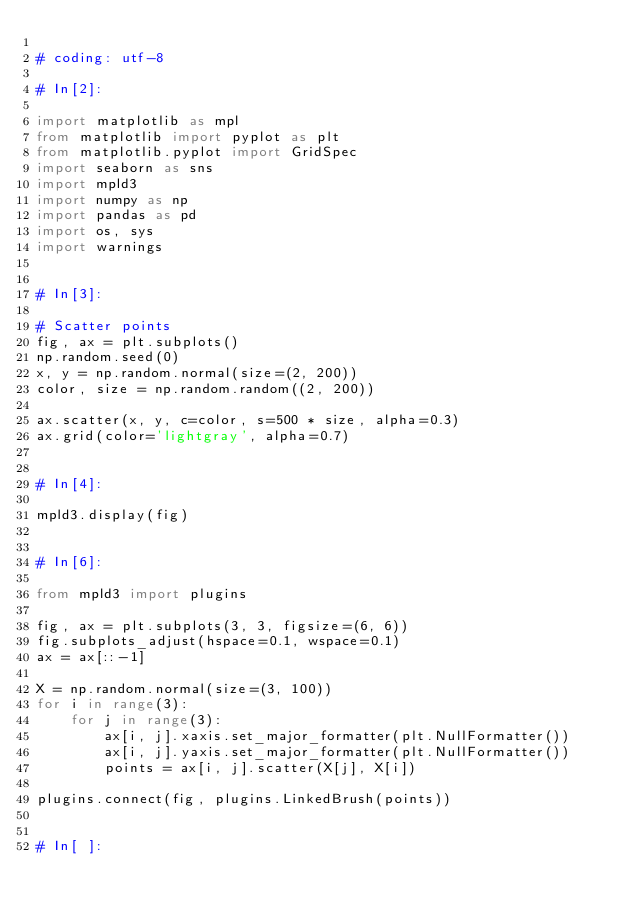Convert code to text. <code><loc_0><loc_0><loc_500><loc_500><_Python_>
# coding: utf-8

# In[2]:

import matplotlib as mpl
from matplotlib import pyplot as plt
from matplotlib.pyplot import GridSpec
import seaborn as sns
import mpld3
import numpy as np
import pandas as pd
import os, sys
import warnings


# In[3]:

# Scatter points
fig, ax = plt.subplots()
np.random.seed(0)
x, y = np.random.normal(size=(2, 200))
color, size = np.random.random((2, 200))

ax.scatter(x, y, c=color, s=500 * size, alpha=0.3)
ax.grid(color='lightgray', alpha=0.7)


# In[4]:

mpld3.display(fig)


# In[6]:

from mpld3 import plugins

fig, ax = plt.subplots(3, 3, figsize=(6, 6))
fig.subplots_adjust(hspace=0.1, wspace=0.1)
ax = ax[::-1]

X = np.random.normal(size=(3, 100))
for i in range(3):
    for j in range(3):
        ax[i, j].xaxis.set_major_formatter(plt.NullFormatter())
        ax[i, j].yaxis.set_major_formatter(plt.NullFormatter())
        points = ax[i, j].scatter(X[j], X[i])
        
plugins.connect(fig, plugins.LinkedBrush(points))


# In[ ]:



</code> 